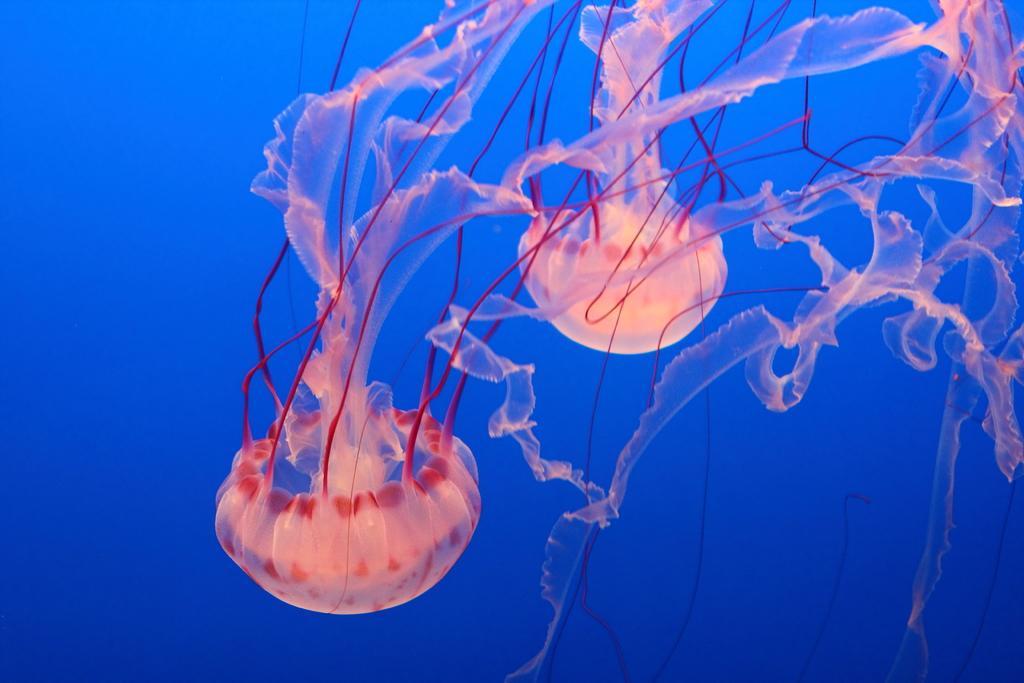Can you describe this image briefly? These are the jelly fishes inside the water. 